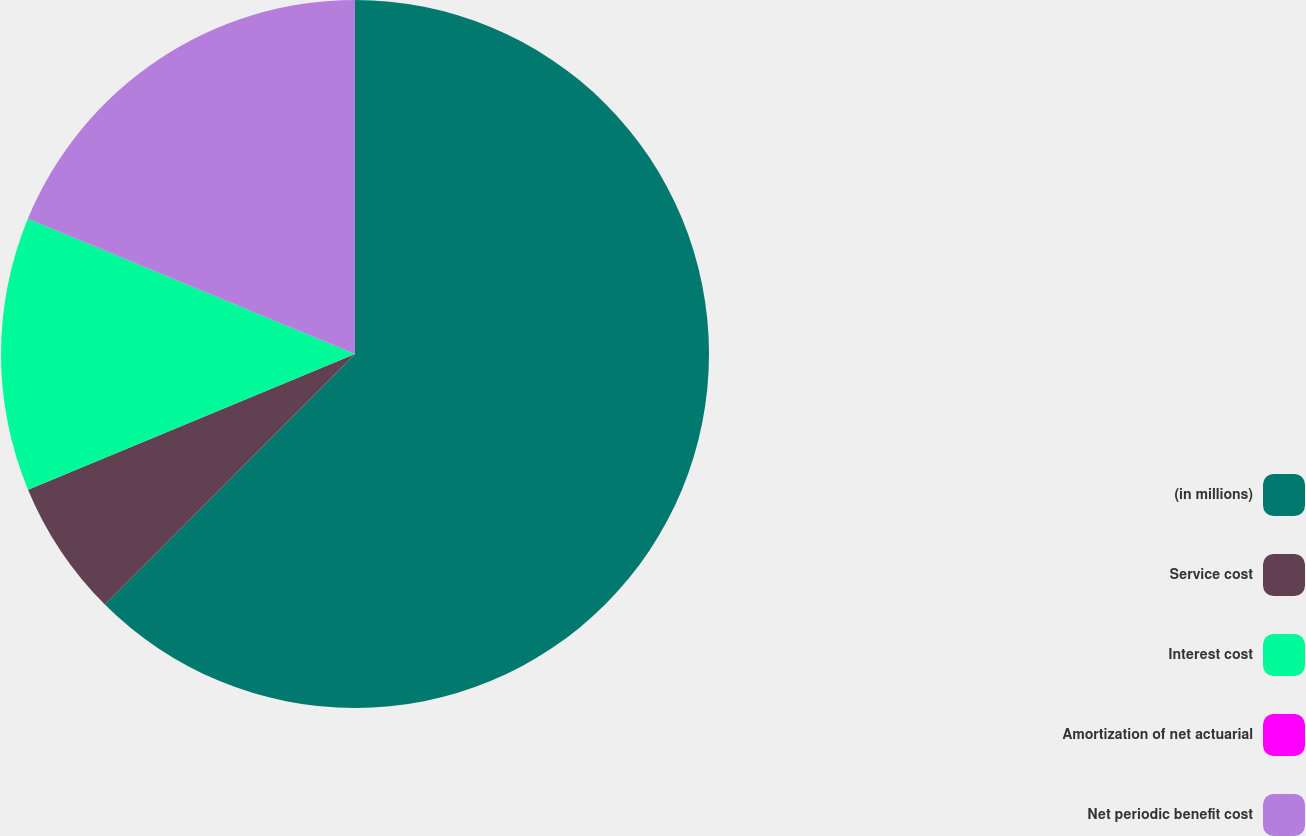Convert chart to OTSL. <chart><loc_0><loc_0><loc_500><loc_500><pie_chart><fcel>(in millions)<fcel>Service cost<fcel>Interest cost<fcel>Amortization of net actuarial<fcel>Net periodic benefit cost<nl><fcel>62.49%<fcel>6.25%<fcel>12.5%<fcel>0.01%<fcel>18.75%<nl></chart> 